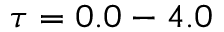<formula> <loc_0><loc_0><loc_500><loc_500>\tau = 0 . 0 - 4 . 0</formula> 